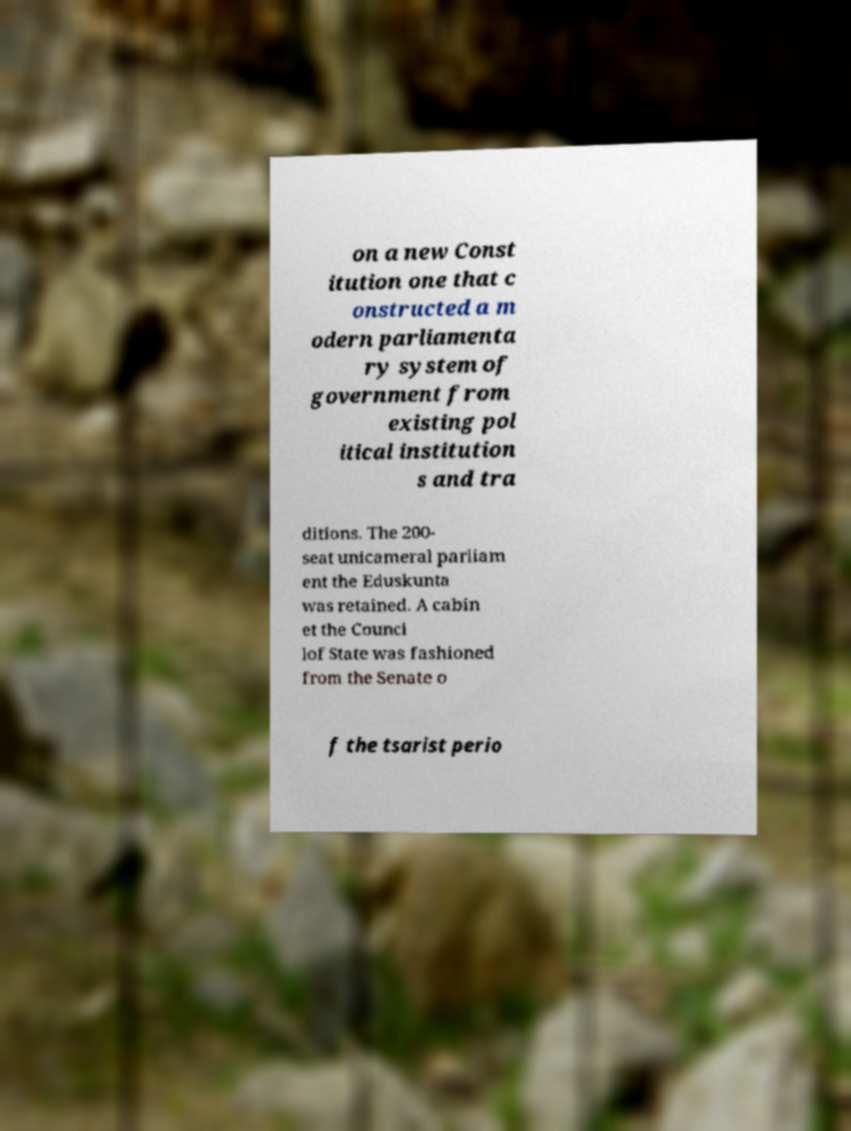Could you assist in decoding the text presented in this image and type it out clearly? on a new Const itution one that c onstructed a m odern parliamenta ry system of government from existing pol itical institution s and tra ditions. The 200- seat unicameral parliam ent the Eduskunta was retained. A cabin et the Counci lof State was fashioned from the Senate o f the tsarist perio 